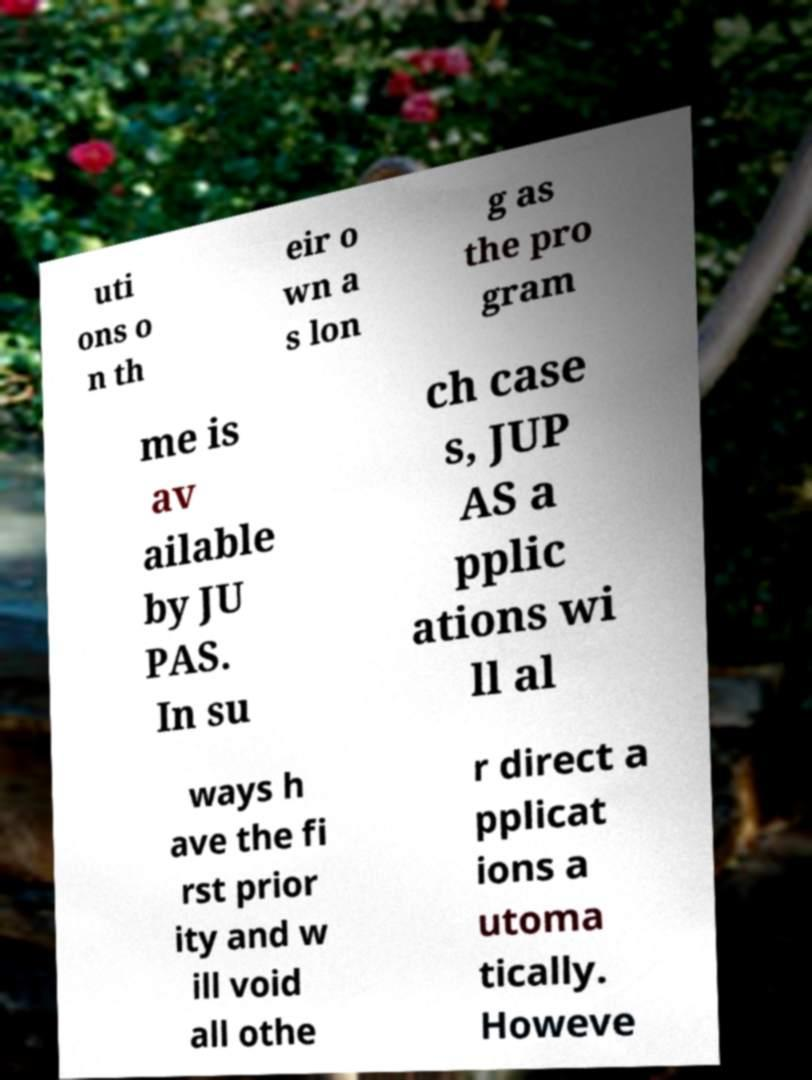Can you accurately transcribe the text from the provided image for me? uti ons o n th eir o wn a s lon g as the pro gram me is av ailable by JU PAS. In su ch case s, JUP AS a pplic ations wi ll al ways h ave the fi rst prior ity and w ill void all othe r direct a pplicat ions a utoma tically. Howeve 